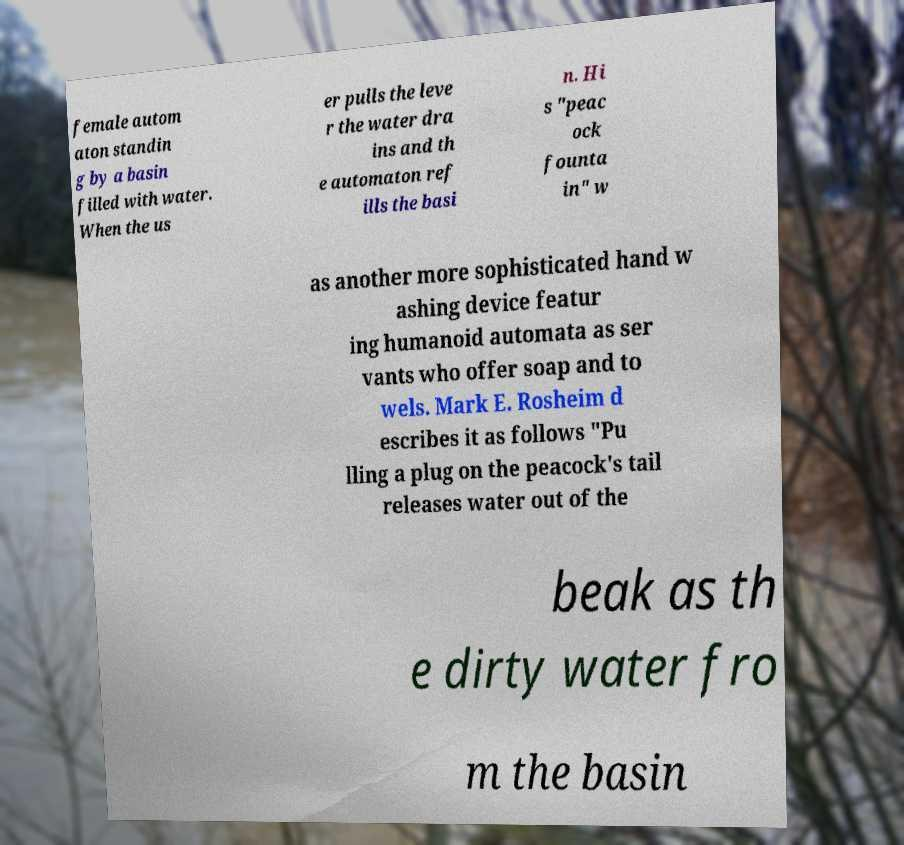For documentation purposes, I need the text within this image transcribed. Could you provide that? female autom aton standin g by a basin filled with water. When the us er pulls the leve r the water dra ins and th e automaton ref ills the basi n. Hi s "peac ock founta in" w as another more sophisticated hand w ashing device featur ing humanoid automata as ser vants who offer soap and to wels. Mark E. Rosheim d escribes it as follows "Pu lling a plug on the peacock's tail releases water out of the beak as th e dirty water fro m the basin 